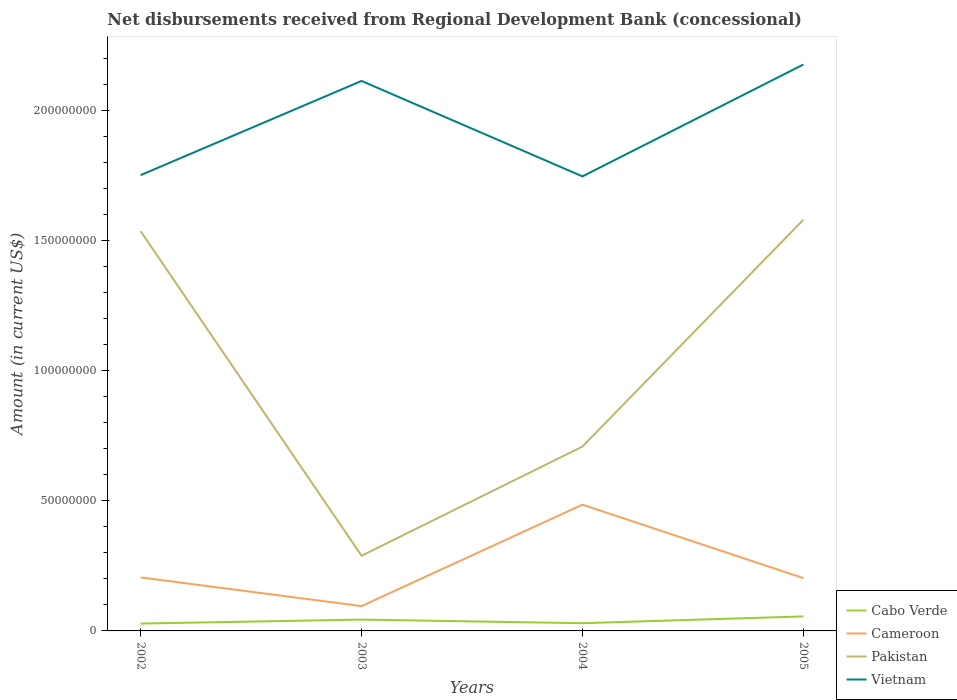Does the line corresponding to Pakistan intersect with the line corresponding to Vietnam?
Make the answer very short. No. Across all years, what is the maximum amount of disbursements received from Regional Development Bank in Cabo Verde?
Your answer should be compact. 2.83e+06. In which year was the amount of disbursements received from Regional Development Bank in Cameroon maximum?
Offer a terse response. 2003. What is the total amount of disbursements received from Regional Development Bank in Vietnam in the graph?
Offer a very short reply. 4.75e+05. What is the difference between the highest and the second highest amount of disbursements received from Regional Development Bank in Pakistan?
Your answer should be compact. 1.29e+08. How many lines are there?
Your answer should be compact. 4. Does the graph contain any zero values?
Offer a very short reply. No. Does the graph contain grids?
Your response must be concise. No. How are the legend labels stacked?
Your response must be concise. Vertical. What is the title of the graph?
Provide a short and direct response. Net disbursements received from Regional Development Bank (concessional). What is the label or title of the X-axis?
Offer a very short reply. Years. What is the Amount (in current US$) of Cabo Verde in 2002?
Offer a terse response. 2.83e+06. What is the Amount (in current US$) of Cameroon in 2002?
Give a very brief answer. 2.06e+07. What is the Amount (in current US$) in Pakistan in 2002?
Your answer should be very brief. 1.54e+08. What is the Amount (in current US$) in Vietnam in 2002?
Your answer should be compact. 1.75e+08. What is the Amount (in current US$) of Cabo Verde in 2003?
Your response must be concise. 4.35e+06. What is the Amount (in current US$) of Cameroon in 2003?
Provide a short and direct response. 9.54e+06. What is the Amount (in current US$) of Pakistan in 2003?
Keep it short and to the point. 2.89e+07. What is the Amount (in current US$) in Vietnam in 2003?
Make the answer very short. 2.11e+08. What is the Amount (in current US$) of Cabo Verde in 2004?
Make the answer very short. 2.97e+06. What is the Amount (in current US$) in Cameroon in 2004?
Your answer should be compact. 4.85e+07. What is the Amount (in current US$) in Pakistan in 2004?
Make the answer very short. 7.08e+07. What is the Amount (in current US$) in Vietnam in 2004?
Keep it short and to the point. 1.75e+08. What is the Amount (in current US$) of Cabo Verde in 2005?
Provide a short and direct response. 5.58e+06. What is the Amount (in current US$) of Cameroon in 2005?
Provide a succinct answer. 2.03e+07. What is the Amount (in current US$) of Pakistan in 2005?
Provide a succinct answer. 1.58e+08. What is the Amount (in current US$) in Vietnam in 2005?
Provide a short and direct response. 2.18e+08. Across all years, what is the maximum Amount (in current US$) in Cabo Verde?
Give a very brief answer. 5.58e+06. Across all years, what is the maximum Amount (in current US$) in Cameroon?
Give a very brief answer. 4.85e+07. Across all years, what is the maximum Amount (in current US$) in Pakistan?
Provide a short and direct response. 1.58e+08. Across all years, what is the maximum Amount (in current US$) in Vietnam?
Your answer should be compact. 2.18e+08. Across all years, what is the minimum Amount (in current US$) in Cabo Verde?
Your response must be concise. 2.83e+06. Across all years, what is the minimum Amount (in current US$) of Cameroon?
Your response must be concise. 9.54e+06. Across all years, what is the minimum Amount (in current US$) of Pakistan?
Your answer should be compact. 2.89e+07. Across all years, what is the minimum Amount (in current US$) of Vietnam?
Your answer should be compact. 1.75e+08. What is the total Amount (in current US$) of Cabo Verde in the graph?
Give a very brief answer. 1.57e+07. What is the total Amount (in current US$) of Cameroon in the graph?
Provide a short and direct response. 9.89e+07. What is the total Amount (in current US$) of Pakistan in the graph?
Provide a short and direct response. 4.11e+08. What is the total Amount (in current US$) of Vietnam in the graph?
Provide a short and direct response. 7.79e+08. What is the difference between the Amount (in current US$) of Cabo Verde in 2002 and that in 2003?
Keep it short and to the point. -1.53e+06. What is the difference between the Amount (in current US$) in Cameroon in 2002 and that in 2003?
Your response must be concise. 1.10e+07. What is the difference between the Amount (in current US$) of Pakistan in 2002 and that in 2003?
Provide a succinct answer. 1.25e+08. What is the difference between the Amount (in current US$) in Vietnam in 2002 and that in 2003?
Keep it short and to the point. -3.62e+07. What is the difference between the Amount (in current US$) in Cabo Verde in 2002 and that in 2004?
Offer a very short reply. -1.42e+05. What is the difference between the Amount (in current US$) in Cameroon in 2002 and that in 2004?
Your response must be concise. -2.79e+07. What is the difference between the Amount (in current US$) in Pakistan in 2002 and that in 2004?
Keep it short and to the point. 8.28e+07. What is the difference between the Amount (in current US$) in Vietnam in 2002 and that in 2004?
Keep it short and to the point. 4.75e+05. What is the difference between the Amount (in current US$) of Cabo Verde in 2002 and that in 2005?
Ensure brevity in your answer.  -2.75e+06. What is the difference between the Amount (in current US$) in Cameroon in 2002 and that in 2005?
Your answer should be compact. 2.62e+05. What is the difference between the Amount (in current US$) of Pakistan in 2002 and that in 2005?
Keep it short and to the point. -4.39e+06. What is the difference between the Amount (in current US$) of Vietnam in 2002 and that in 2005?
Ensure brevity in your answer.  -4.25e+07. What is the difference between the Amount (in current US$) of Cabo Verde in 2003 and that in 2004?
Give a very brief answer. 1.38e+06. What is the difference between the Amount (in current US$) in Cameroon in 2003 and that in 2004?
Provide a short and direct response. -3.90e+07. What is the difference between the Amount (in current US$) of Pakistan in 2003 and that in 2004?
Your answer should be very brief. -4.19e+07. What is the difference between the Amount (in current US$) of Vietnam in 2003 and that in 2004?
Offer a terse response. 3.67e+07. What is the difference between the Amount (in current US$) in Cabo Verde in 2003 and that in 2005?
Give a very brief answer. -1.22e+06. What is the difference between the Amount (in current US$) in Cameroon in 2003 and that in 2005?
Provide a succinct answer. -1.08e+07. What is the difference between the Amount (in current US$) of Pakistan in 2003 and that in 2005?
Give a very brief answer. -1.29e+08. What is the difference between the Amount (in current US$) in Vietnam in 2003 and that in 2005?
Your response must be concise. -6.31e+06. What is the difference between the Amount (in current US$) in Cabo Verde in 2004 and that in 2005?
Offer a very short reply. -2.61e+06. What is the difference between the Amount (in current US$) in Cameroon in 2004 and that in 2005?
Provide a succinct answer. 2.82e+07. What is the difference between the Amount (in current US$) of Pakistan in 2004 and that in 2005?
Offer a very short reply. -8.71e+07. What is the difference between the Amount (in current US$) of Vietnam in 2004 and that in 2005?
Provide a succinct answer. -4.30e+07. What is the difference between the Amount (in current US$) in Cabo Verde in 2002 and the Amount (in current US$) in Cameroon in 2003?
Your answer should be compact. -6.71e+06. What is the difference between the Amount (in current US$) in Cabo Verde in 2002 and the Amount (in current US$) in Pakistan in 2003?
Provide a succinct answer. -2.61e+07. What is the difference between the Amount (in current US$) in Cabo Verde in 2002 and the Amount (in current US$) in Vietnam in 2003?
Keep it short and to the point. -2.08e+08. What is the difference between the Amount (in current US$) in Cameroon in 2002 and the Amount (in current US$) in Pakistan in 2003?
Keep it short and to the point. -8.32e+06. What is the difference between the Amount (in current US$) of Cameroon in 2002 and the Amount (in current US$) of Vietnam in 2003?
Offer a very short reply. -1.91e+08. What is the difference between the Amount (in current US$) in Pakistan in 2002 and the Amount (in current US$) in Vietnam in 2003?
Give a very brief answer. -5.77e+07. What is the difference between the Amount (in current US$) of Cabo Verde in 2002 and the Amount (in current US$) of Cameroon in 2004?
Provide a succinct answer. -4.57e+07. What is the difference between the Amount (in current US$) of Cabo Verde in 2002 and the Amount (in current US$) of Pakistan in 2004?
Your answer should be compact. -6.80e+07. What is the difference between the Amount (in current US$) of Cabo Verde in 2002 and the Amount (in current US$) of Vietnam in 2004?
Your response must be concise. -1.72e+08. What is the difference between the Amount (in current US$) of Cameroon in 2002 and the Amount (in current US$) of Pakistan in 2004?
Your answer should be very brief. -5.03e+07. What is the difference between the Amount (in current US$) of Cameroon in 2002 and the Amount (in current US$) of Vietnam in 2004?
Provide a succinct answer. -1.54e+08. What is the difference between the Amount (in current US$) of Pakistan in 2002 and the Amount (in current US$) of Vietnam in 2004?
Ensure brevity in your answer.  -2.11e+07. What is the difference between the Amount (in current US$) in Cabo Verde in 2002 and the Amount (in current US$) in Cameroon in 2005?
Give a very brief answer. -1.75e+07. What is the difference between the Amount (in current US$) of Cabo Verde in 2002 and the Amount (in current US$) of Pakistan in 2005?
Give a very brief answer. -1.55e+08. What is the difference between the Amount (in current US$) of Cabo Verde in 2002 and the Amount (in current US$) of Vietnam in 2005?
Keep it short and to the point. -2.15e+08. What is the difference between the Amount (in current US$) in Cameroon in 2002 and the Amount (in current US$) in Pakistan in 2005?
Make the answer very short. -1.37e+08. What is the difference between the Amount (in current US$) of Cameroon in 2002 and the Amount (in current US$) of Vietnam in 2005?
Make the answer very short. -1.97e+08. What is the difference between the Amount (in current US$) in Pakistan in 2002 and the Amount (in current US$) in Vietnam in 2005?
Offer a terse response. -6.40e+07. What is the difference between the Amount (in current US$) of Cabo Verde in 2003 and the Amount (in current US$) of Cameroon in 2004?
Provide a short and direct response. -4.42e+07. What is the difference between the Amount (in current US$) of Cabo Verde in 2003 and the Amount (in current US$) of Pakistan in 2004?
Your answer should be very brief. -6.65e+07. What is the difference between the Amount (in current US$) in Cabo Verde in 2003 and the Amount (in current US$) in Vietnam in 2004?
Ensure brevity in your answer.  -1.70e+08. What is the difference between the Amount (in current US$) in Cameroon in 2003 and the Amount (in current US$) in Pakistan in 2004?
Your answer should be compact. -6.13e+07. What is the difference between the Amount (in current US$) of Cameroon in 2003 and the Amount (in current US$) of Vietnam in 2004?
Your response must be concise. -1.65e+08. What is the difference between the Amount (in current US$) in Pakistan in 2003 and the Amount (in current US$) in Vietnam in 2004?
Offer a very short reply. -1.46e+08. What is the difference between the Amount (in current US$) of Cabo Verde in 2003 and the Amount (in current US$) of Cameroon in 2005?
Provide a short and direct response. -1.60e+07. What is the difference between the Amount (in current US$) of Cabo Verde in 2003 and the Amount (in current US$) of Pakistan in 2005?
Offer a terse response. -1.54e+08. What is the difference between the Amount (in current US$) in Cabo Verde in 2003 and the Amount (in current US$) in Vietnam in 2005?
Keep it short and to the point. -2.13e+08. What is the difference between the Amount (in current US$) in Cameroon in 2003 and the Amount (in current US$) in Pakistan in 2005?
Your answer should be very brief. -1.48e+08. What is the difference between the Amount (in current US$) of Cameroon in 2003 and the Amount (in current US$) of Vietnam in 2005?
Keep it short and to the point. -2.08e+08. What is the difference between the Amount (in current US$) in Pakistan in 2003 and the Amount (in current US$) in Vietnam in 2005?
Provide a succinct answer. -1.89e+08. What is the difference between the Amount (in current US$) in Cabo Verde in 2004 and the Amount (in current US$) in Cameroon in 2005?
Your answer should be very brief. -1.73e+07. What is the difference between the Amount (in current US$) in Cabo Verde in 2004 and the Amount (in current US$) in Pakistan in 2005?
Make the answer very short. -1.55e+08. What is the difference between the Amount (in current US$) of Cabo Verde in 2004 and the Amount (in current US$) of Vietnam in 2005?
Offer a very short reply. -2.15e+08. What is the difference between the Amount (in current US$) of Cameroon in 2004 and the Amount (in current US$) of Pakistan in 2005?
Offer a very short reply. -1.09e+08. What is the difference between the Amount (in current US$) of Cameroon in 2004 and the Amount (in current US$) of Vietnam in 2005?
Keep it short and to the point. -1.69e+08. What is the difference between the Amount (in current US$) of Pakistan in 2004 and the Amount (in current US$) of Vietnam in 2005?
Your answer should be very brief. -1.47e+08. What is the average Amount (in current US$) in Cabo Verde per year?
Make the answer very short. 3.93e+06. What is the average Amount (in current US$) of Cameroon per year?
Your answer should be compact. 2.47e+07. What is the average Amount (in current US$) of Pakistan per year?
Your answer should be compact. 1.03e+08. What is the average Amount (in current US$) of Vietnam per year?
Provide a succinct answer. 1.95e+08. In the year 2002, what is the difference between the Amount (in current US$) in Cabo Verde and Amount (in current US$) in Cameroon?
Your response must be concise. -1.77e+07. In the year 2002, what is the difference between the Amount (in current US$) in Cabo Verde and Amount (in current US$) in Pakistan?
Keep it short and to the point. -1.51e+08. In the year 2002, what is the difference between the Amount (in current US$) in Cabo Verde and Amount (in current US$) in Vietnam?
Your answer should be very brief. -1.72e+08. In the year 2002, what is the difference between the Amount (in current US$) in Cameroon and Amount (in current US$) in Pakistan?
Keep it short and to the point. -1.33e+08. In the year 2002, what is the difference between the Amount (in current US$) in Cameroon and Amount (in current US$) in Vietnam?
Provide a succinct answer. -1.55e+08. In the year 2002, what is the difference between the Amount (in current US$) in Pakistan and Amount (in current US$) in Vietnam?
Ensure brevity in your answer.  -2.15e+07. In the year 2003, what is the difference between the Amount (in current US$) of Cabo Verde and Amount (in current US$) of Cameroon?
Provide a short and direct response. -5.18e+06. In the year 2003, what is the difference between the Amount (in current US$) in Cabo Verde and Amount (in current US$) in Pakistan?
Keep it short and to the point. -2.45e+07. In the year 2003, what is the difference between the Amount (in current US$) in Cabo Verde and Amount (in current US$) in Vietnam?
Provide a succinct answer. -2.07e+08. In the year 2003, what is the difference between the Amount (in current US$) in Cameroon and Amount (in current US$) in Pakistan?
Your answer should be compact. -1.93e+07. In the year 2003, what is the difference between the Amount (in current US$) of Cameroon and Amount (in current US$) of Vietnam?
Your answer should be very brief. -2.02e+08. In the year 2003, what is the difference between the Amount (in current US$) of Pakistan and Amount (in current US$) of Vietnam?
Keep it short and to the point. -1.82e+08. In the year 2004, what is the difference between the Amount (in current US$) of Cabo Verde and Amount (in current US$) of Cameroon?
Your response must be concise. -4.55e+07. In the year 2004, what is the difference between the Amount (in current US$) in Cabo Verde and Amount (in current US$) in Pakistan?
Give a very brief answer. -6.79e+07. In the year 2004, what is the difference between the Amount (in current US$) of Cabo Verde and Amount (in current US$) of Vietnam?
Your answer should be compact. -1.72e+08. In the year 2004, what is the difference between the Amount (in current US$) of Cameroon and Amount (in current US$) of Pakistan?
Your response must be concise. -2.23e+07. In the year 2004, what is the difference between the Amount (in current US$) in Cameroon and Amount (in current US$) in Vietnam?
Your answer should be very brief. -1.26e+08. In the year 2004, what is the difference between the Amount (in current US$) of Pakistan and Amount (in current US$) of Vietnam?
Make the answer very short. -1.04e+08. In the year 2005, what is the difference between the Amount (in current US$) of Cabo Verde and Amount (in current US$) of Cameroon?
Keep it short and to the point. -1.47e+07. In the year 2005, what is the difference between the Amount (in current US$) in Cabo Verde and Amount (in current US$) in Pakistan?
Your response must be concise. -1.52e+08. In the year 2005, what is the difference between the Amount (in current US$) of Cabo Verde and Amount (in current US$) of Vietnam?
Ensure brevity in your answer.  -2.12e+08. In the year 2005, what is the difference between the Amount (in current US$) of Cameroon and Amount (in current US$) of Pakistan?
Your answer should be very brief. -1.38e+08. In the year 2005, what is the difference between the Amount (in current US$) in Cameroon and Amount (in current US$) in Vietnam?
Offer a very short reply. -1.97e+08. In the year 2005, what is the difference between the Amount (in current US$) of Pakistan and Amount (in current US$) of Vietnam?
Offer a very short reply. -5.96e+07. What is the ratio of the Amount (in current US$) in Cabo Verde in 2002 to that in 2003?
Ensure brevity in your answer.  0.65. What is the ratio of the Amount (in current US$) of Cameroon in 2002 to that in 2003?
Offer a very short reply. 2.16. What is the ratio of the Amount (in current US$) in Pakistan in 2002 to that in 2003?
Make the answer very short. 5.32. What is the ratio of the Amount (in current US$) of Vietnam in 2002 to that in 2003?
Your answer should be compact. 0.83. What is the ratio of the Amount (in current US$) of Cabo Verde in 2002 to that in 2004?
Offer a very short reply. 0.95. What is the ratio of the Amount (in current US$) of Cameroon in 2002 to that in 2004?
Give a very brief answer. 0.42. What is the ratio of the Amount (in current US$) of Pakistan in 2002 to that in 2004?
Provide a succinct answer. 2.17. What is the ratio of the Amount (in current US$) of Vietnam in 2002 to that in 2004?
Ensure brevity in your answer.  1. What is the ratio of the Amount (in current US$) of Cabo Verde in 2002 to that in 2005?
Ensure brevity in your answer.  0.51. What is the ratio of the Amount (in current US$) of Cameroon in 2002 to that in 2005?
Your response must be concise. 1.01. What is the ratio of the Amount (in current US$) in Pakistan in 2002 to that in 2005?
Your answer should be very brief. 0.97. What is the ratio of the Amount (in current US$) of Vietnam in 2002 to that in 2005?
Provide a succinct answer. 0.8. What is the ratio of the Amount (in current US$) in Cabo Verde in 2003 to that in 2004?
Provide a succinct answer. 1.47. What is the ratio of the Amount (in current US$) of Cameroon in 2003 to that in 2004?
Give a very brief answer. 0.2. What is the ratio of the Amount (in current US$) in Pakistan in 2003 to that in 2004?
Keep it short and to the point. 0.41. What is the ratio of the Amount (in current US$) in Vietnam in 2003 to that in 2004?
Your answer should be compact. 1.21. What is the ratio of the Amount (in current US$) in Cabo Verde in 2003 to that in 2005?
Offer a very short reply. 0.78. What is the ratio of the Amount (in current US$) of Cameroon in 2003 to that in 2005?
Provide a short and direct response. 0.47. What is the ratio of the Amount (in current US$) in Pakistan in 2003 to that in 2005?
Ensure brevity in your answer.  0.18. What is the ratio of the Amount (in current US$) of Cabo Verde in 2004 to that in 2005?
Your answer should be very brief. 0.53. What is the ratio of the Amount (in current US$) of Cameroon in 2004 to that in 2005?
Keep it short and to the point. 2.39. What is the ratio of the Amount (in current US$) of Pakistan in 2004 to that in 2005?
Make the answer very short. 0.45. What is the ratio of the Amount (in current US$) of Vietnam in 2004 to that in 2005?
Offer a very short reply. 0.8. What is the difference between the highest and the second highest Amount (in current US$) of Cabo Verde?
Provide a short and direct response. 1.22e+06. What is the difference between the highest and the second highest Amount (in current US$) of Cameroon?
Give a very brief answer. 2.79e+07. What is the difference between the highest and the second highest Amount (in current US$) in Pakistan?
Give a very brief answer. 4.39e+06. What is the difference between the highest and the second highest Amount (in current US$) in Vietnam?
Offer a very short reply. 6.31e+06. What is the difference between the highest and the lowest Amount (in current US$) in Cabo Verde?
Ensure brevity in your answer.  2.75e+06. What is the difference between the highest and the lowest Amount (in current US$) of Cameroon?
Provide a succinct answer. 3.90e+07. What is the difference between the highest and the lowest Amount (in current US$) in Pakistan?
Provide a succinct answer. 1.29e+08. What is the difference between the highest and the lowest Amount (in current US$) of Vietnam?
Offer a very short reply. 4.30e+07. 